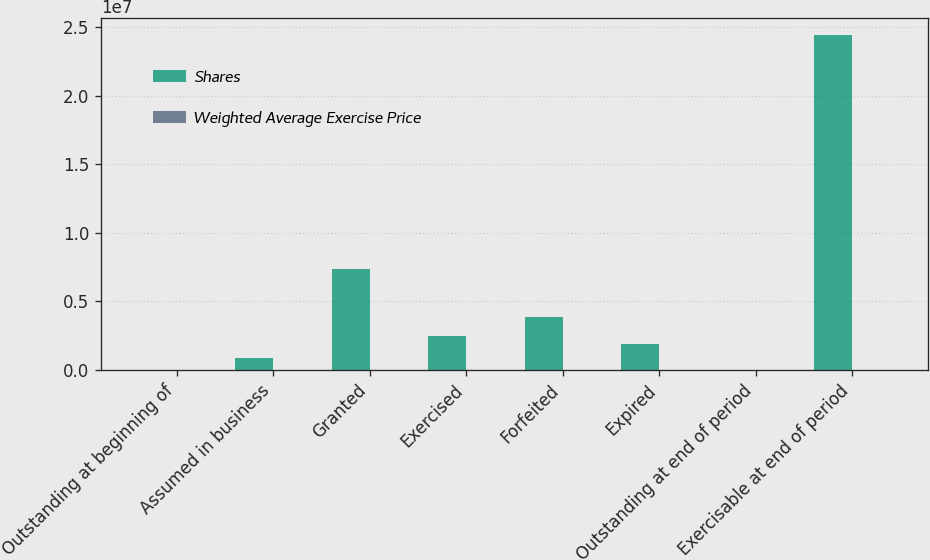<chart> <loc_0><loc_0><loc_500><loc_500><stacked_bar_chart><ecel><fcel>Outstanding at beginning of<fcel>Assumed in business<fcel>Granted<fcel>Exercised<fcel>Forfeited<fcel>Expired<fcel>Outstanding at end of period<fcel>Exercisable at end of period<nl><fcel>Shares<fcel>40.26<fcel>846953<fcel>7.38726e+06<fcel>2.4669e+06<fcel>3.85995e+06<fcel>1.90342e+06<fcel>40.26<fcel>2.4474e+07<nl><fcel>Weighted Average Exercise Price<fcel>31.51<fcel>1.99<fcel>20.5<fcel>12.4<fcel>41.27<fcel>39.25<fcel>28.38<fcel>32.69<nl></chart> 